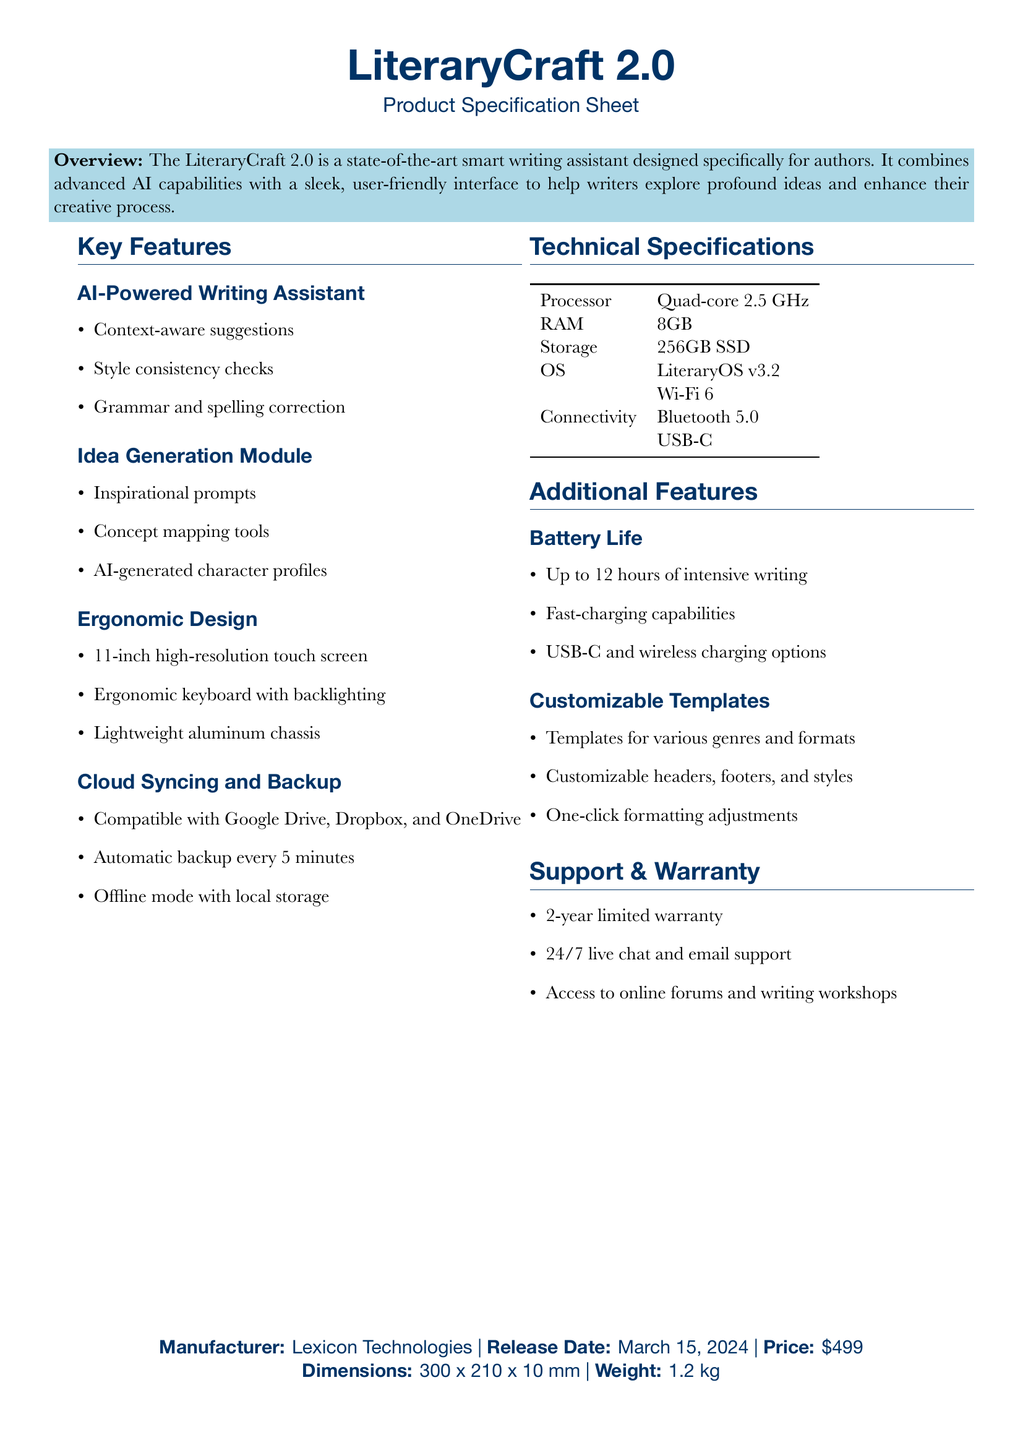What is the product name? The product name is mentioned at the beginning of the document as LiteraryCraft 2.0.
Answer: LiteraryCraft 2.0 When is the release date? The release date is specified in the document as March 15, 2024.
Answer: March 15, 2024 What is the price of the device? The price is noted in the document as 499 dollars.
Answer: 499 dollars What is the battery life? The document states that the battery life can last up to 12 hours of intensive writing.
Answer: 12 hours Which OS does the device use? The OS is specified in the technical specifications as LiteraryOS v3.2.
Answer: LiteraryOS v3.2 What kind of support is provided? The support section mentions 24/7 live chat and email support.
Answer: 24/7 live chat and email support What is one of the additional charging options? The additional charging options include wireless charging, as listed under battery life.
Answer: Wireless charging What is the weight of the device? The weight is provided at the end of the document as 1.2 kilograms.
Answer: 1.2 kilograms How many templates are customizable? The document specifies that there are templates for various genres and formats, indicating multiple options.
Answer: Various genres and formats 